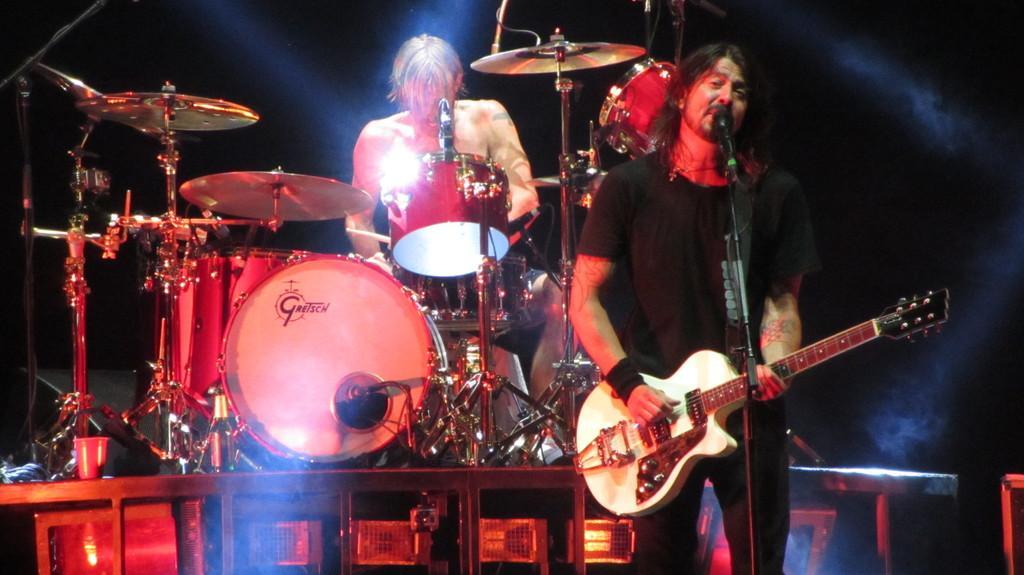In one or two sentences, can you explain what this image depicts? in this image I can see two people where one is standing and holding a guitar and another one is sitting next to a drum set. I can also see a mic in front of him. 